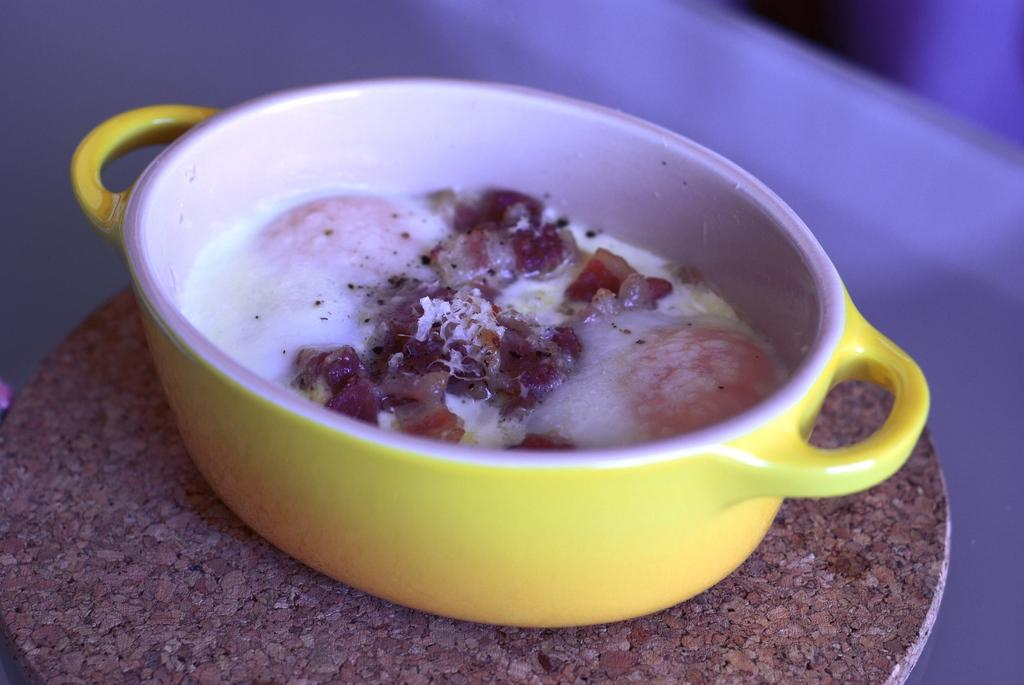What is the color of the utensil in the image? The utensil in the image is yellow and white. What is inside the utensil? There is a food item in the utensil. What type of board is being used to cook the food in the image? There is no board present in the image; it features a yellow and white utensil with a food item inside. Is the food item in the utensil currently burning? The image does not show any indication of the food item burning. 